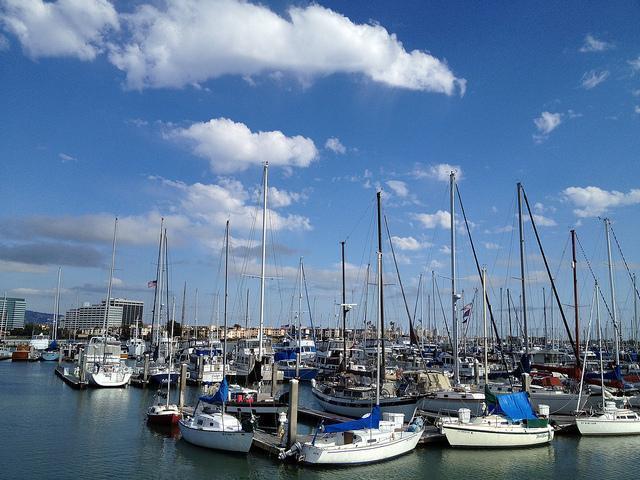Which object on one of the boats would help someone prepare for rain?
Indicate the correct response by choosing from the four available options to answer the question.
Options: Bucket, tarp, sail, motor. Tarp. 